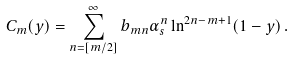<formula> <loc_0><loc_0><loc_500><loc_500>C _ { m } ( y ) = \sum _ { n = [ m / 2 ] } ^ { \infty } b _ { m n } \alpha _ { s } ^ { n } \ln ^ { 2 n - m + 1 } ( 1 - y ) \, .</formula> 